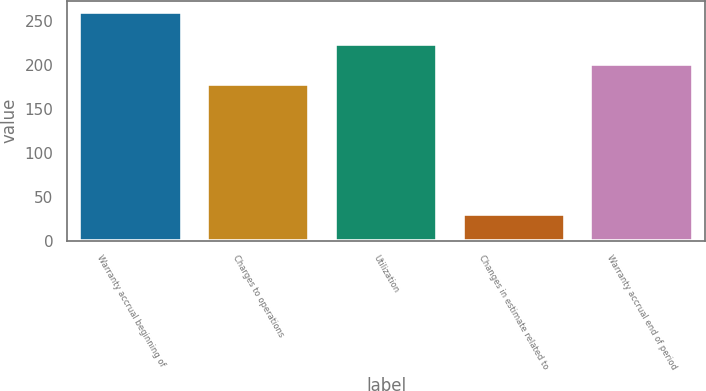Convert chart. <chart><loc_0><loc_0><loc_500><loc_500><bar_chart><fcel>Warranty accrual beginning of<fcel>Charges to operations<fcel>Utilization<fcel>Changes in estimate related to<fcel>Warranty accrual end of period<nl><fcel>260<fcel>178<fcel>224<fcel>30<fcel>201<nl></chart> 